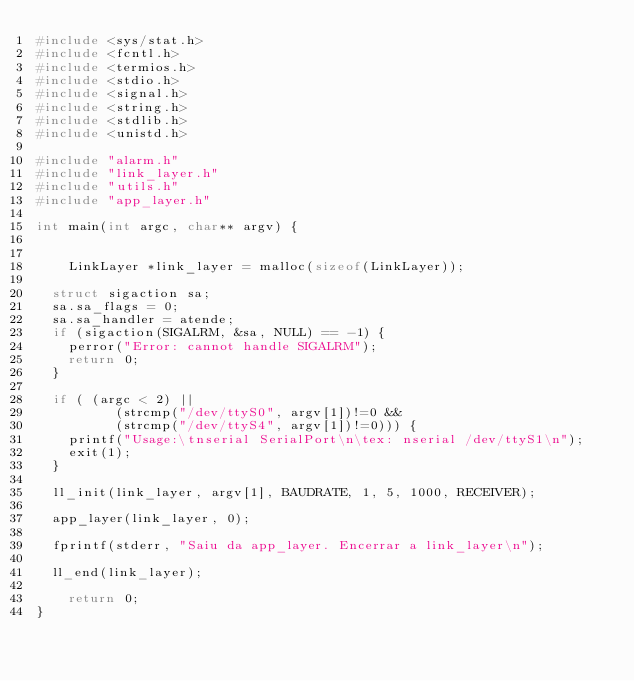<code> <loc_0><loc_0><loc_500><loc_500><_C_>#include <sys/stat.h>
#include <fcntl.h>
#include <termios.h>
#include <stdio.h>
#include <signal.h>
#include <string.h>
#include <stdlib.h>
#include <unistd.h>

#include "alarm.h"
#include "link_layer.h"
#include "utils.h"
#include "app_layer.h"

int main(int argc, char** argv) {
    
	
  	LinkLayer *link_layer = malloc(sizeof(LinkLayer));

  struct sigaction sa;
  sa.sa_flags = 0;
  sa.sa_handler = atende;
  if (sigaction(SIGALRM, &sa, NULL) == -1) {
    perror("Error: cannot handle SIGALRM");
    return 0;
  }

  if ( (argc < 2) || 
	      (strcmp("/dev/ttyS0", argv[1])!=0 && 
	      (strcmp("/dev/ttyS4", argv[1])!=0))) {
    printf("Usage:\tnserial SerialPort\n\tex: nserial /dev/ttyS1\n");
    exit(1);
  }

  ll_init(link_layer, argv[1], BAUDRATE, 1, 5, 1000, RECEIVER); 

  app_layer(link_layer, 0);

  fprintf(stderr, "Saiu da app_layer. Encerrar a link_layer\n");

  ll_end(link_layer);

	return 0;
}
</code> 